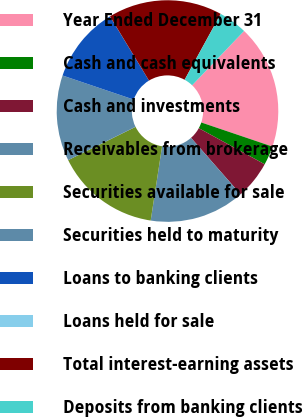Convert chart. <chart><loc_0><loc_0><loc_500><loc_500><pie_chart><fcel>Year Ended December 31<fcel>Cash and cash equivalents<fcel>Cash and investments<fcel>Receivables from brokerage<fcel>Securities available for sale<fcel>Securities held to maturity<fcel>Loans to banking clients<fcel>Loans held for sale<fcel>Total interest-earning assets<fcel>Deposits from banking clients<nl><fcel>18.05%<fcel>2.78%<fcel>5.56%<fcel>13.89%<fcel>15.27%<fcel>12.5%<fcel>11.11%<fcel>0.01%<fcel>16.66%<fcel>4.17%<nl></chart> 